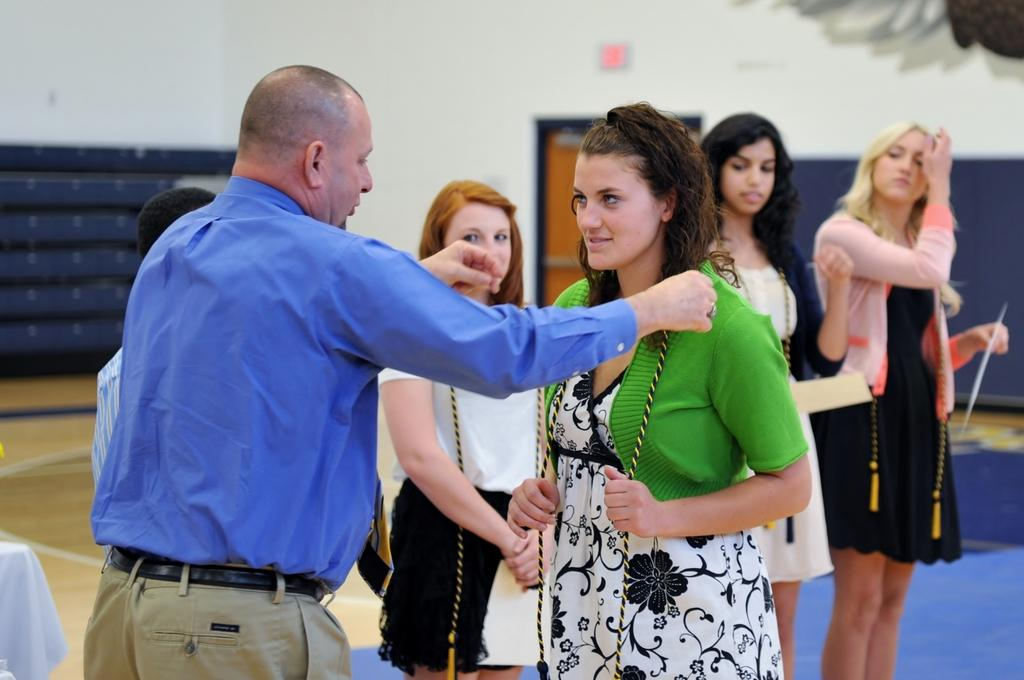How many people are in the image? There is a group of people standing in the image. What is the woman holding in the image? The woman is holding a stick. What type of furniture is present in the image? There is a table in the image. What architectural feature can be seen in the image? There is a door in the image. What is hanging on the wall in the image? There is a signboard and a picture on a wall in the image. What type of oven is visible in the image? There is no oven present in the image. How does the heart affect the memory of the people in the image? There is no mention of hearts or memories in the image; it features a group of people, a woman holding a stick, a table, a door, a signboard, and a picture on a wall. 